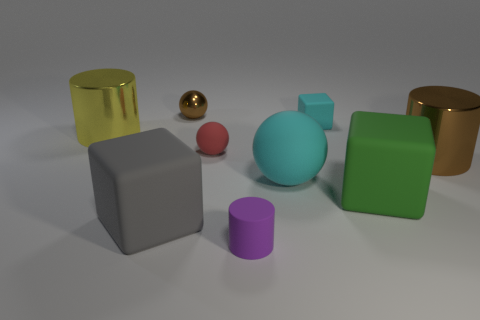Subtract 1 cylinders. How many cylinders are left? 2 Subtract all large yellow cylinders. How many cylinders are left? 2 Subtract all gray balls. Subtract all blue cylinders. How many balls are left? 3 Subtract 0 red cylinders. How many objects are left? 9 Subtract all spheres. How many objects are left? 6 Subtract all large green blocks. Subtract all green balls. How many objects are left? 8 Add 4 tiny red things. How many tiny red things are left? 5 Add 5 gray cubes. How many gray cubes exist? 6 